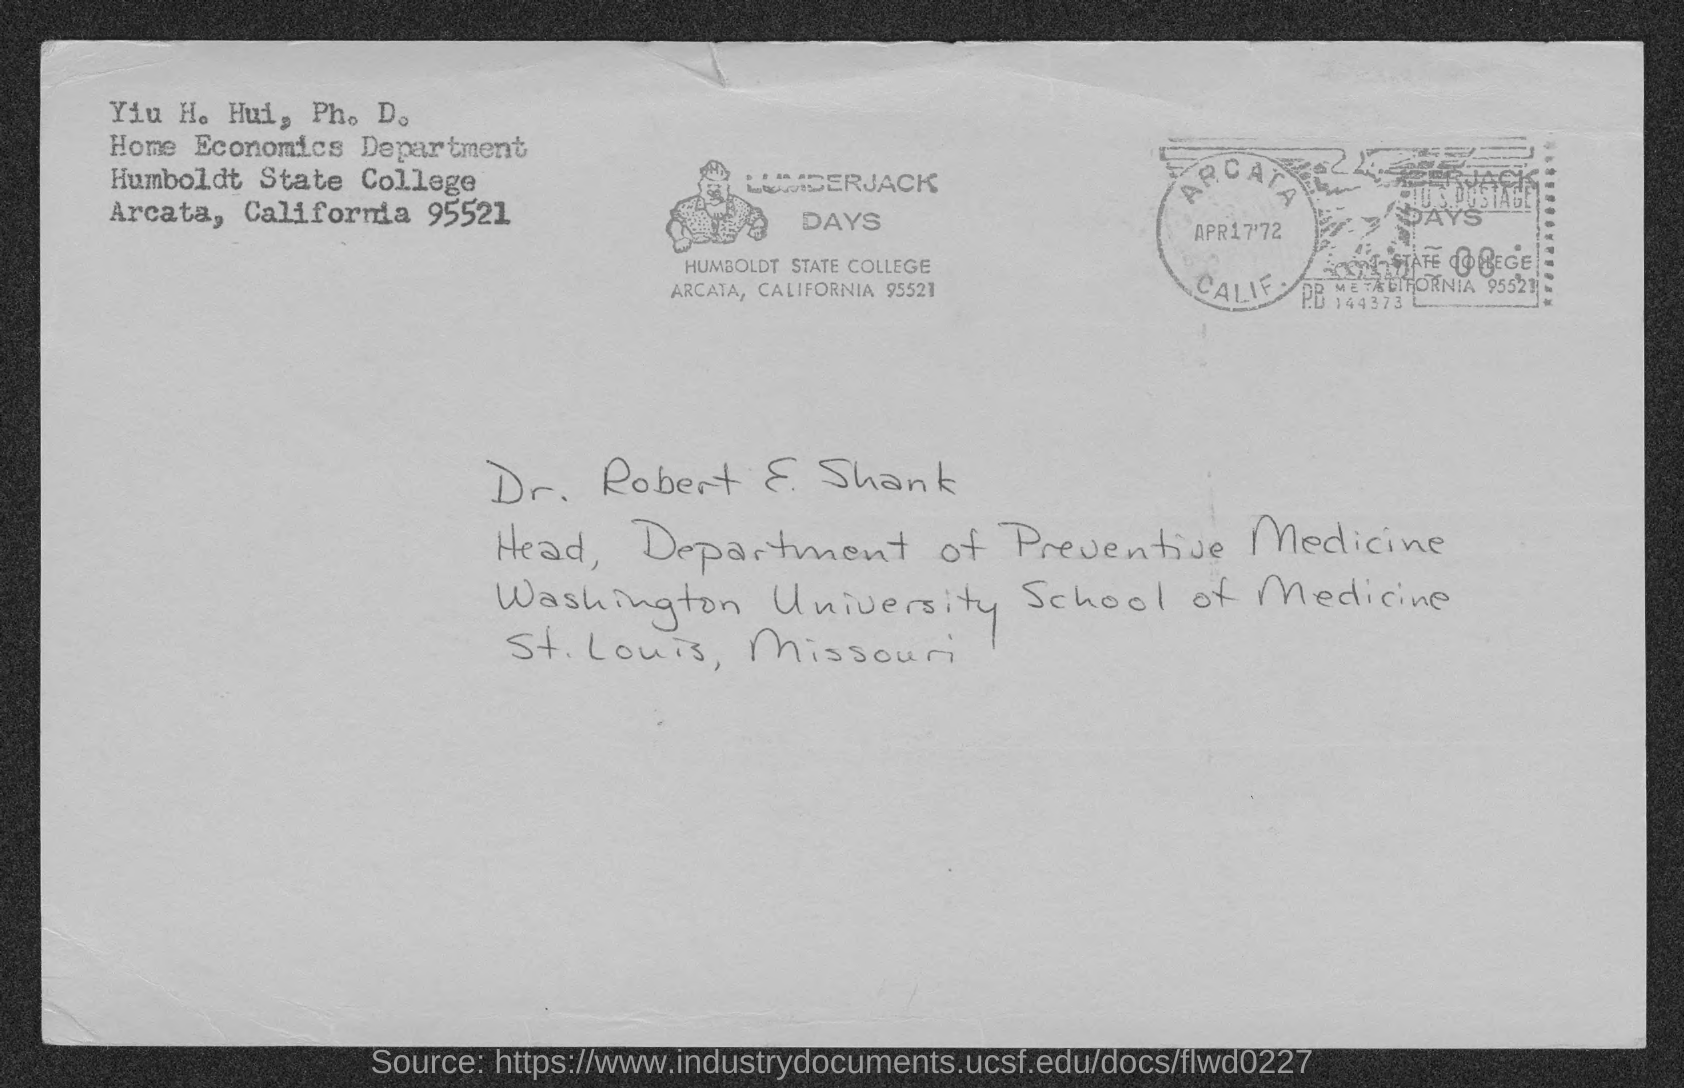What is the name of the college ?
Ensure brevity in your answer.  Humboldt State College. Where is Humboldt State College located ?
Offer a terse response. ARCATA, CALIFORNIA. What is the designation of  Dr. Robert E Shank
Keep it short and to the point. HEAD, DEPARTMENT OF PREVENTIVE MEDICINE. What is the name of the university mentioned  ?
Offer a very short reply. Washington University school of medicine. 